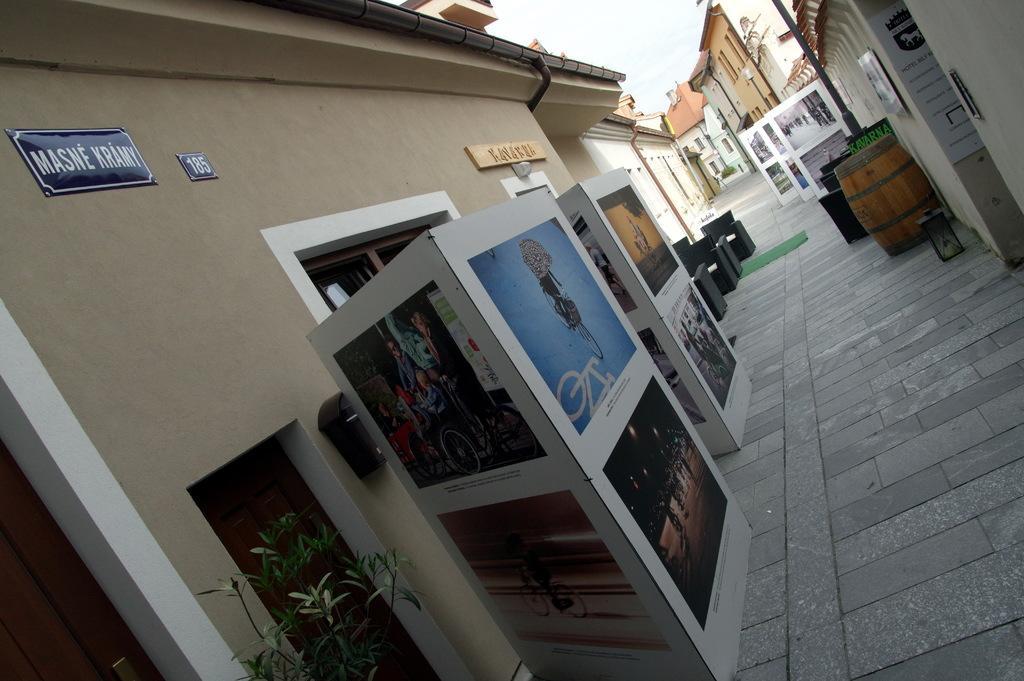Please provide a concise description of this image. In this picture there is a advertising Banner board in front. Behind there is a brown color wall with with windows and doors. On the right side we can see a lane with cobbler stones and brown color drum. In the background there are some buildings in the lane. 